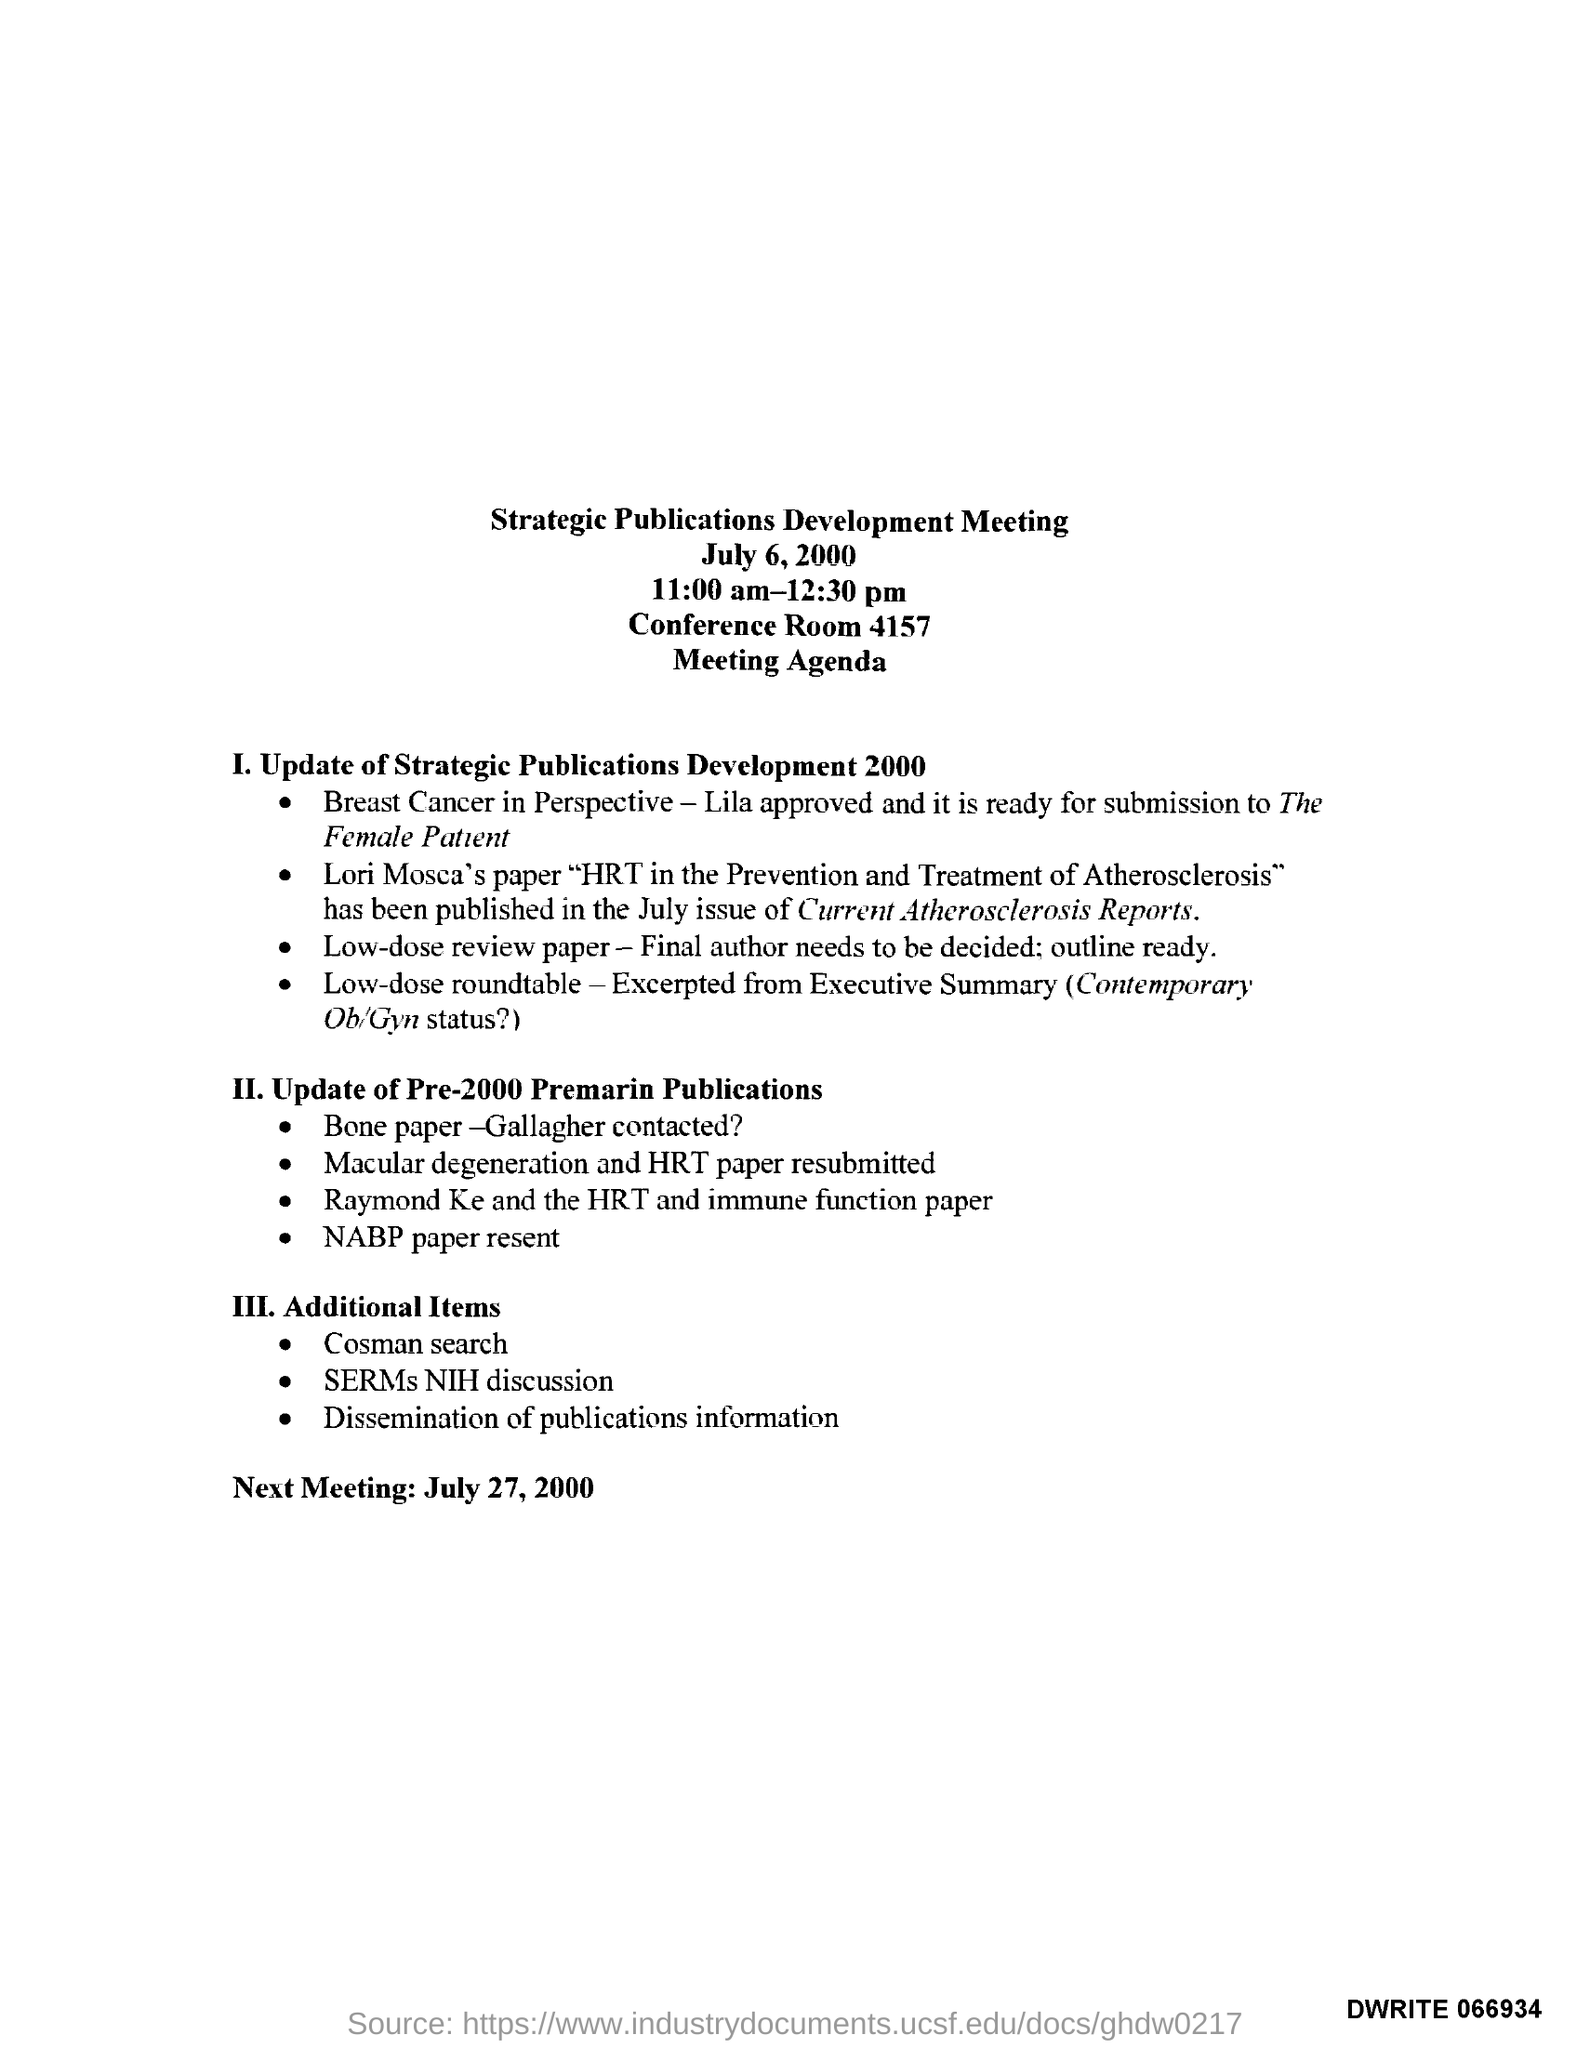Give some essential details in this illustration. What is the date of the next meeting? The date mentioned at the top of the document is July 6, 2000. The conference room number is 4157. The timing of the meeting is from 11:00 am to 12:30 pm. 